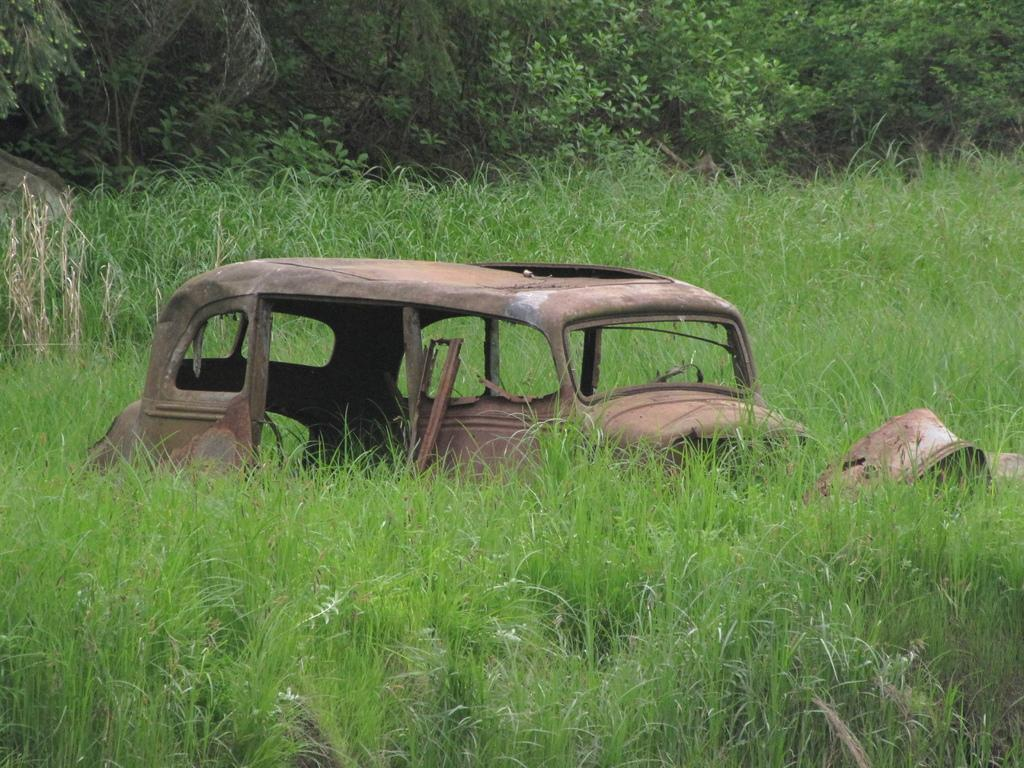What type of vehicle can be seen in the image? There is an old vehicle in the image. What is the ground surface like in the image? There is grass on the ground in the image. What can be seen in the background of the image? There are trees in the background of the image. How many legs does the owl have in the image? There is no owl present in the image, so it is not possible to determine the number of legs it might have. 